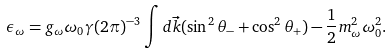<formula> <loc_0><loc_0><loc_500><loc_500>\epsilon _ { \omega } = g _ { \omega } \omega _ { 0 } \gamma ( 2 \pi ) ^ { - 3 } \int d \vec { k } ( \sin ^ { 2 } \theta _ { - } + \cos ^ { 2 } \theta _ { + } ) - \frac { 1 } { 2 } m _ { \omega } ^ { 2 } \omega _ { 0 } ^ { 2 } .</formula> 